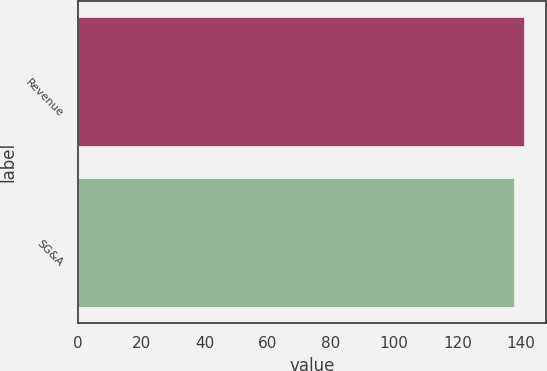Convert chart. <chart><loc_0><loc_0><loc_500><loc_500><bar_chart><fcel>Revenue<fcel>SG&A<nl><fcel>141<fcel>138<nl></chart> 